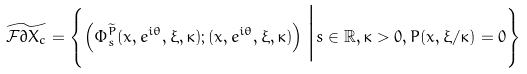Convert formula to latex. <formula><loc_0><loc_0><loc_500><loc_500>\widetilde { \mathcal { F } \partial X _ { c } } = \left \{ \left ( \Phi _ { s } ^ { \widetilde { P } } ( x , e ^ { i \theta } , \xi , \kappa ) ; ( x , e ^ { i \theta } , \xi , \kappa ) \right ) \Big | s \in \mathbb { R } , \kappa > 0 , P ( x , \xi / \kappa ) = 0 \right \}</formula> 